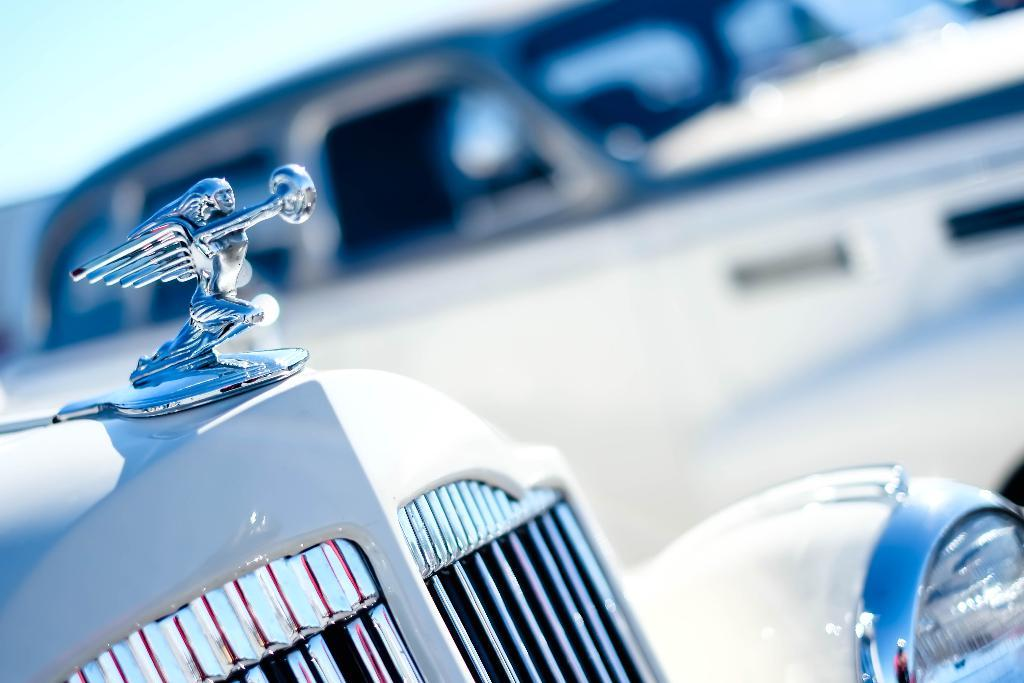What is the main subject of the image? The main subject of the image is a vehicle with an emblem. Can you describe the background of the image? The background behind the vehicle is blurred. What part of the natural environment is visible in the image? The sky is visible in the top left corner of the image. What type of idea is being discussed in the image? There is no discussion or idea present in the image; it features a vehicle with an emblem and a blurred background. 